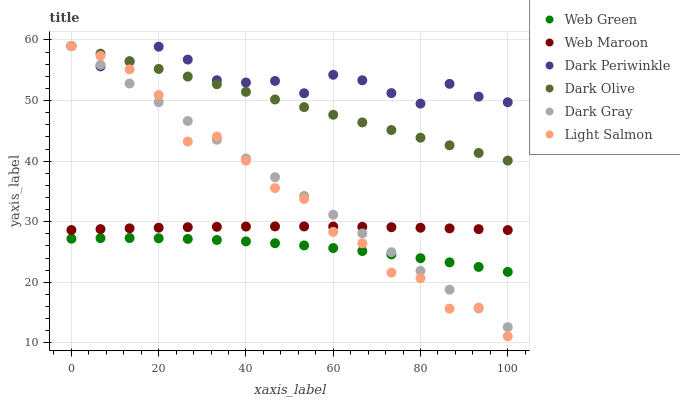Does Web Green have the minimum area under the curve?
Answer yes or no. Yes. Does Dark Periwinkle have the maximum area under the curve?
Answer yes or no. Yes. Does Dark Olive have the minimum area under the curve?
Answer yes or no. No. Does Dark Olive have the maximum area under the curve?
Answer yes or no. No. Is Dark Olive the smoothest?
Answer yes or no. Yes. Is Light Salmon the roughest?
Answer yes or no. Yes. Is Web Maroon the smoothest?
Answer yes or no. No. Is Web Maroon the roughest?
Answer yes or no. No. Does Light Salmon have the lowest value?
Answer yes or no. Yes. Does Dark Olive have the lowest value?
Answer yes or no. No. Does Dark Periwinkle have the highest value?
Answer yes or no. Yes. Does Web Maroon have the highest value?
Answer yes or no. No. Is Web Green less than Dark Periwinkle?
Answer yes or no. Yes. Is Dark Periwinkle greater than Web Green?
Answer yes or no. Yes. Does Dark Olive intersect Light Salmon?
Answer yes or no. Yes. Is Dark Olive less than Light Salmon?
Answer yes or no. No. Is Dark Olive greater than Light Salmon?
Answer yes or no. No. Does Web Green intersect Dark Periwinkle?
Answer yes or no. No. 